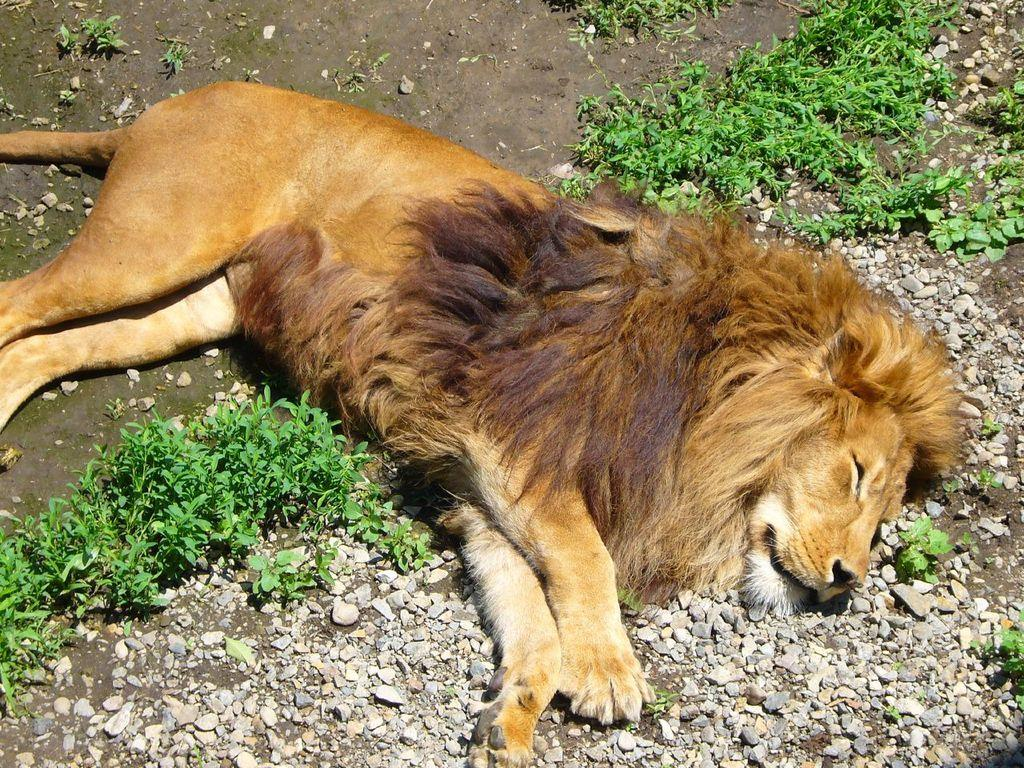What is the main subject of the image? There is an animal lying on the ground in the image. Can you describe the appearance of the animal? The animal is in brown and black colors. What type of terrain is visible in the image? There is grass and rocks on the ground in the image. What type of punishment is the animal receiving in the image? There is no indication of punishment in the image; the animal is simply lying on the ground. What kind of noise can be heard coming from the animal in the image? The image is static, so no noise can be heard from the animal. 